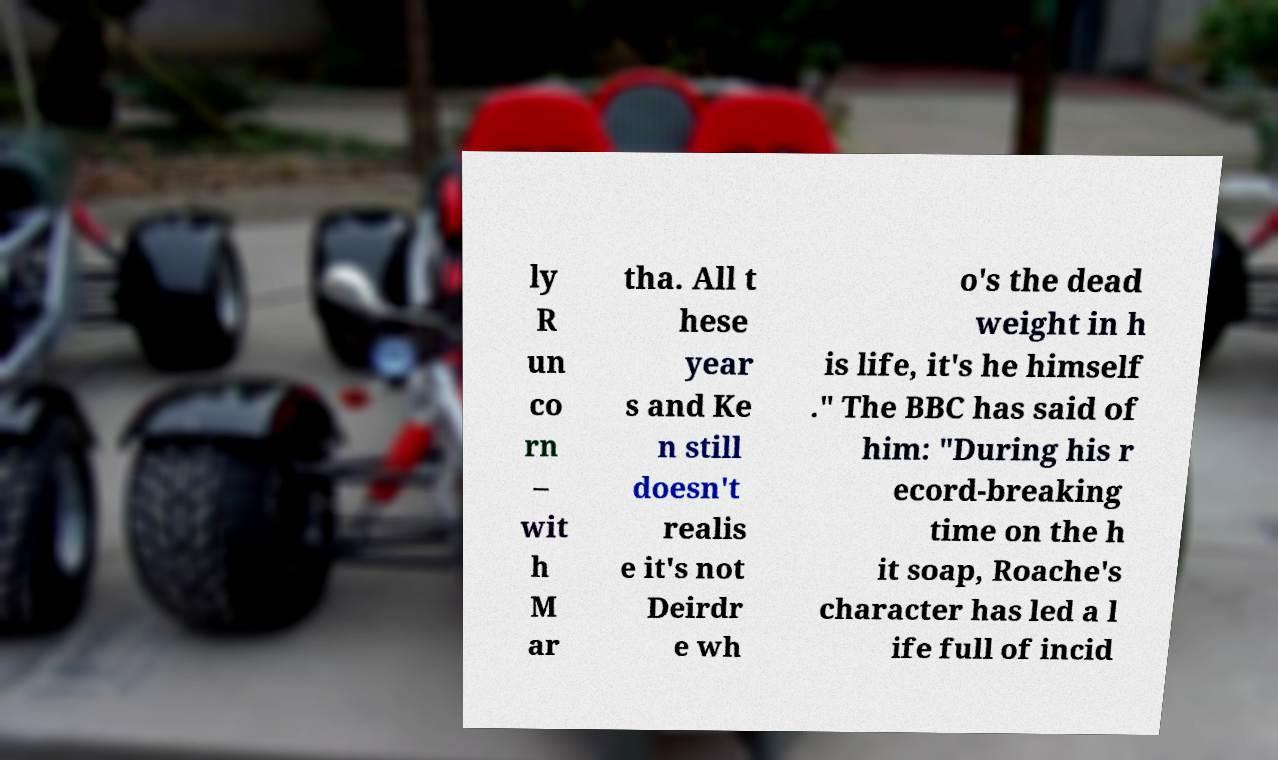What messages or text are displayed in this image? I need them in a readable, typed format. ly R un co rn – wit h M ar tha. All t hese year s and Ke n still doesn't realis e it's not Deirdr e wh o's the dead weight in h is life, it's he himself ." The BBC has said of him: "During his r ecord-breaking time on the h it soap, Roache's character has led a l ife full of incid 